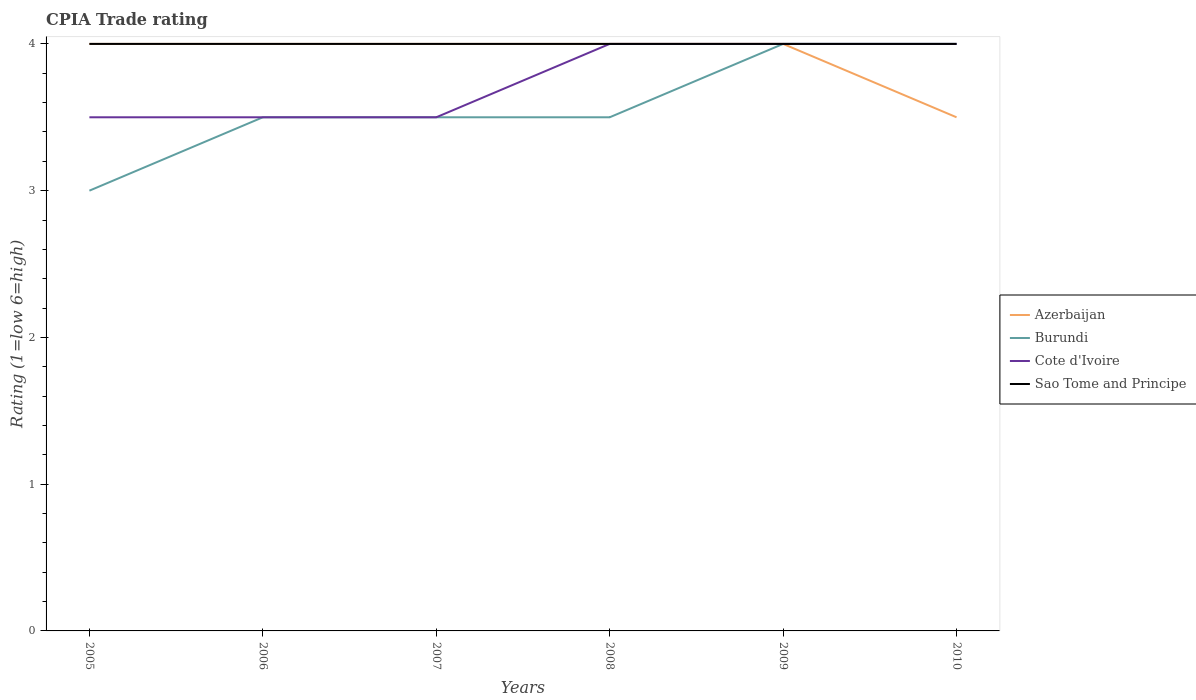In which year was the CPIA rating in Cote d'Ivoire maximum?
Provide a succinct answer. 2005. What is the total CPIA rating in Cote d'Ivoire in the graph?
Offer a very short reply. -0.5. What is the difference between the highest and the second highest CPIA rating in Sao Tome and Principe?
Keep it short and to the point. 0. What is the difference between the highest and the lowest CPIA rating in Azerbaijan?
Your response must be concise. 5. Is the CPIA rating in Cote d'Ivoire strictly greater than the CPIA rating in Azerbaijan over the years?
Ensure brevity in your answer.  No. How many lines are there?
Your answer should be very brief. 4. How many years are there in the graph?
Offer a very short reply. 6. Does the graph contain grids?
Provide a short and direct response. No. What is the title of the graph?
Your answer should be very brief. CPIA Trade rating. Does "Albania" appear as one of the legend labels in the graph?
Offer a terse response. No. What is the Rating (1=low 6=high) in Azerbaijan in 2005?
Keep it short and to the point. 4. What is the Rating (1=low 6=high) in Burundi in 2005?
Your answer should be very brief. 3. What is the Rating (1=low 6=high) in Azerbaijan in 2006?
Offer a terse response. 4. What is the Rating (1=low 6=high) in Cote d'Ivoire in 2006?
Provide a succinct answer. 3.5. What is the Rating (1=low 6=high) in Azerbaijan in 2007?
Provide a succinct answer. 4. What is the Rating (1=low 6=high) in Burundi in 2007?
Offer a very short reply. 3.5. What is the Rating (1=low 6=high) in Cote d'Ivoire in 2007?
Offer a terse response. 3.5. What is the Rating (1=low 6=high) of Azerbaijan in 2008?
Your answer should be very brief. 4. What is the Rating (1=low 6=high) of Burundi in 2008?
Provide a short and direct response. 3.5. What is the Rating (1=low 6=high) of Cote d'Ivoire in 2008?
Provide a short and direct response. 4. What is the Rating (1=low 6=high) in Azerbaijan in 2009?
Provide a succinct answer. 4. What is the Rating (1=low 6=high) in Burundi in 2009?
Ensure brevity in your answer.  4. What is the Rating (1=low 6=high) of Azerbaijan in 2010?
Your answer should be compact. 3.5. What is the Rating (1=low 6=high) in Sao Tome and Principe in 2010?
Provide a succinct answer. 4. Across all years, what is the maximum Rating (1=low 6=high) in Azerbaijan?
Offer a very short reply. 4. Across all years, what is the maximum Rating (1=low 6=high) in Burundi?
Your answer should be compact. 4. Across all years, what is the maximum Rating (1=low 6=high) of Sao Tome and Principe?
Provide a succinct answer. 4. Across all years, what is the minimum Rating (1=low 6=high) in Azerbaijan?
Provide a succinct answer. 3.5. Across all years, what is the minimum Rating (1=low 6=high) in Burundi?
Your answer should be very brief. 3. Across all years, what is the minimum Rating (1=low 6=high) of Sao Tome and Principe?
Your response must be concise. 4. What is the total Rating (1=low 6=high) of Azerbaijan in the graph?
Your answer should be very brief. 23.5. What is the total Rating (1=low 6=high) of Burundi in the graph?
Your answer should be compact. 21.5. What is the total Rating (1=low 6=high) of Cote d'Ivoire in the graph?
Offer a terse response. 22.5. What is the total Rating (1=low 6=high) of Sao Tome and Principe in the graph?
Provide a succinct answer. 24. What is the difference between the Rating (1=low 6=high) in Azerbaijan in 2005 and that in 2006?
Make the answer very short. 0. What is the difference between the Rating (1=low 6=high) in Cote d'Ivoire in 2005 and that in 2006?
Give a very brief answer. 0. What is the difference between the Rating (1=low 6=high) of Azerbaijan in 2005 and that in 2007?
Your answer should be very brief. 0. What is the difference between the Rating (1=low 6=high) in Cote d'Ivoire in 2005 and that in 2008?
Provide a succinct answer. -0.5. What is the difference between the Rating (1=low 6=high) of Azerbaijan in 2005 and that in 2009?
Ensure brevity in your answer.  0. What is the difference between the Rating (1=low 6=high) in Cote d'Ivoire in 2005 and that in 2009?
Your response must be concise. -0.5. What is the difference between the Rating (1=low 6=high) of Sao Tome and Principe in 2005 and that in 2009?
Offer a terse response. 0. What is the difference between the Rating (1=low 6=high) in Azerbaijan in 2005 and that in 2010?
Ensure brevity in your answer.  0.5. What is the difference between the Rating (1=low 6=high) in Sao Tome and Principe in 2006 and that in 2007?
Make the answer very short. 0. What is the difference between the Rating (1=low 6=high) in Azerbaijan in 2006 and that in 2008?
Provide a succinct answer. 0. What is the difference between the Rating (1=low 6=high) in Sao Tome and Principe in 2006 and that in 2008?
Provide a short and direct response. 0. What is the difference between the Rating (1=low 6=high) of Sao Tome and Principe in 2006 and that in 2009?
Your answer should be compact. 0. What is the difference between the Rating (1=low 6=high) of Burundi in 2006 and that in 2010?
Provide a short and direct response. -0.5. What is the difference between the Rating (1=low 6=high) of Azerbaijan in 2007 and that in 2008?
Give a very brief answer. 0. What is the difference between the Rating (1=low 6=high) of Burundi in 2007 and that in 2008?
Give a very brief answer. 0. What is the difference between the Rating (1=low 6=high) of Azerbaijan in 2007 and that in 2009?
Make the answer very short. 0. What is the difference between the Rating (1=low 6=high) of Burundi in 2007 and that in 2009?
Provide a succinct answer. -0.5. What is the difference between the Rating (1=low 6=high) in Cote d'Ivoire in 2007 and that in 2009?
Provide a succinct answer. -0.5. What is the difference between the Rating (1=low 6=high) in Sao Tome and Principe in 2007 and that in 2009?
Your answer should be compact. 0. What is the difference between the Rating (1=low 6=high) in Azerbaijan in 2007 and that in 2010?
Provide a succinct answer. 0.5. What is the difference between the Rating (1=low 6=high) in Sao Tome and Principe in 2007 and that in 2010?
Provide a succinct answer. 0. What is the difference between the Rating (1=low 6=high) of Azerbaijan in 2008 and that in 2009?
Your answer should be compact. 0. What is the difference between the Rating (1=low 6=high) of Cote d'Ivoire in 2008 and that in 2009?
Give a very brief answer. 0. What is the difference between the Rating (1=low 6=high) of Cote d'Ivoire in 2008 and that in 2010?
Offer a terse response. 0. What is the difference between the Rating (1=low 6=high) of Sao Tome and Principe in 2008 and that in 2010?
Your response must be concise. 0. What is the difference between the Rating (1=low 6=high) of Cote d'Ivoire in 2009 and that in 2010?
Provide a short and direct response. 0. What is the difference between the Rating (1=low 6=high) in Sao Tome and Principe in 2009 and that in 2010?
Your response must be concise. 0. What is the difference between the Rating (1=low 6=high) of Burundi in 2005 and the Rating (1=low 6=high) of Sao Tome and Principe in 2006?
Ensure brevity in your answer.  -1. What is the difference between the Rating (1=low 6=high) of Azerbaijan in 2005 and the Rating (1=low 6=high) of Sao Tome and Principe in 2007?
Provide a short and direct response. 0. What is the difference between the Rating (1=low 6=high) in Burundi in 2005 and the Rating (1=low 6=high) in Cote d'Ivoire in 2007?
Your answer should be very brief. -0.5. What is the difference between the Rating (1=low 6=high) of Cote d'Ivoire in 2005 and the Rating (1=low 6=high) of Sao Tome and Principe in 2007?
Your answer should be compact. -0.5. What is the difference between the Rating (1=low 6=high) in Burundi in 2005 and the Rating (1=low 6=high) in Cote d'Ivoire in 2008?
Offer a terse response. -1. What is the difference between the Rating (1=low 6=high) in Burundi in 2005 and the Rating (1=low 6=high) in Sao Tome and Principe in 2008?
Your answer should be compact. -1. What is the difference between the Rating (1=low 6=high) of Azerbaijan in 2005 and the Rating (1=low 6=high) of Burundi in 2009?
Provide a succinct answer. 0. What is the difference between the Rating (1=low 6=high) in Azerbaijan in 2005 and the Rating (1=low 6=high) in Sao Tome and Principe in 2009?
Provide a succinct answer. 0. What is the difference between the Rating (1=low 6=high) in Burundi in 2005 and the Rating (1=low 6=high) in Sao Tome and Principe in 2009?
Your response must be concise. -1. What is the difference between the Rating (1=low 6=high) of Azerbaijan in 2005 and the Rating (1=low 6=high) of Cote d'Ivoire in 2010?
Your answer should be compact. 0. What is the difference between the Rating (1=low 6=high) in Burundi in 2005 and the Rating (1=low 6=high) in Cote d'Ivoire in 2010?
Offer a very short reply. -1. What is the difference between the Rating (1=low 6=high) in Cote d'Ivoire in 2005 and the Rating (1=low 6=high) in Sao Tome and Principe in 2010?
Your answer should be compact. -0.5. What is the difference between the Rating (1=low 6=high) of Azerbaijan in 2006 and the Rating (1=low 6=high) of Cote d'Ivoire in 2007?
Make the answer very short. 0.5. What is the difference between the Rating (1=low 6=high) in Azerbaijan in 2006 and the Rating (1=low 6=high) in Sao Tome and Principe in 2007?
Your answer should be compact. 0. What is the difference between the Rating (1=low 6=high) in Burundi in 2006 and the Rating (1=low 6=high) in Cote d'Ivoire in 2007?
Provide a succinct answer. 0. What is the difference between the Rating (1=low 6=high) of Burundi in 2006 and the Rating (1=low 6=high) of Sao Tome and Principe in 2007?
Offer a terse response. -0.5. What is the difference between the Rating (1=low 6=high) of Cote d'Ivoire in 2006 and the Rating (1=low 6=high) of Sao Tome and Principe in 2007?
Keep it short and to the point. -0.5. What is the difference between the Rating (1=low 6=high) of Azerbaijan in 2006 and the Rating (1=low 6=high) of Burundi in 2008?
Offer a very short reply. 0.5. What is the difference between the Rating (1=low 6=high) in Azerbaijan in 2006 and the Rating (1=low 6=high) in Sao Tome and Principe in 2008?
Offer a terse response. 0. What is the difference between the Rating (1=low 6=high) in Burundi in 2006 and the Rating (1=low 6=high) in Sao Tome and Principe in 2008?
Your response must be concise. -0.5. What is the difference between the Rating (1=low 6=high) of Azerbaijan in 2006 and the Rating (1=low 6=high) of Burundi in 2009?
Offer a very short reply. 0. What is the difference between the Rating (1=low 6=high) in Burundi in 2006 and the Rating (1=low 6=high) in Cote d'Ivoire in 2009?
Provide a succinct answer. -0.5. What is the difference between the Rating (1=low 6=high) in Azerbaijan in 2006 and the Rating (1=low 6=high) in Cote d'Ivoire in 2010?
Offer a terse response. 0. What is the difference between the Rating (1=low 6=high) of Azerbaijan in 2006 and the Rating (1=low 6=high) of Sao Tome and Principe in 2010?
Your answer should be very brief. 0. What is the difference between the Rating (1=low 6=high) in Cote d'Ivoire in 2006 and the Rating (1=low 6=high) in Sao Tome and Principe in 2010?
Offer a very short reply. -0.5. What is the difference between the Rating (1=low 6=high) in Azerbaijan in 2007 and the Rating (1=low 6=high) in Sao Tome and Principe in 2008?
Your response must be concise. 0. What is the difference between the Rating (1=low 6=high) in Burundi in 2007 and the Rating (1=low 6=high) in Cote d'Ivoire in 2008?
Your answer should be very brief. -0.5. What is the difference between the Rating (1=low 6=high) of Azerbaijan in 2007 and the Rating (1=low 6=high) of Burundi in 2009?
Offer a terse response. 0. What is the difference between the Rating (1=low 6=high) in Azerbaijan in 2007 and the Rating (1=low 6=high) in Sao Tome and Principe in 2009?
Your response must be concise. 0. What is the difference between the Rating (1=low 6=high) of Burundi in 2007 and the Rating (1=low 6=high) of Cote d'Ivoire in 2009?
Provide a succinct answer. -0.5. What is the difference between the Rating (1=low 6=high) in Burundi in 2007 and the Rating (1=low 6=high) in Sao Tome and Principe in 2009?
Your answer should be very brief. -0.5. What is the difference between the Rating (1=low 6=high) of Cote d'Ivoire in 2007 and the Rating (1=low 6=high) of Sao Tome and Principe in 2009?
Provide a short and direct response. -0.5. What is the difference between the Rating (1=low 6=high) in Azerbaijan in 2007 and the Rating (1=low 6=high) in Burundi in 2010?
Keep it short and to the point. 0. What is the difference between the Rating (1=low 6=high) in Azerbaijan in 2007 and the Rating (1=low 6=high) in Cote d'Ivoire in 2010?
Ensure brevity in your answer.  0. What is the difference between the Rating (1=low 6=high) of Cote d'Ivoire in 2007 and the Rating (1=low 6=high) of Sao Tome and Principe in 2010?
Your answer should be very brief. -0.5. What is the difference between the Rating (1=low 6=high) in Azerbaijan in 2008 and the Rating (1=low 6=high) in Cote d'Ivoire in 2009?
Provide a succinct answer. 0. What is the difference between the Rating (1=low 6=high) in Azerbaijan in 2008 and the Rating (1=low 6=high) in Sao Tome and Principe in 2009?
Provide a succinct answer. 0. What is the difference between the Rating (1=low 6=high) in Burundi in 2008 and the Rating (1=low 6=high) in Cote d'Ivoire in 2009?
Ensure brevity in your answer.  -0.5. What is the difference between the Rating (1=low 6=high) in Burundi in 2008 and the Rating (1=low 6=high) in Sao Tome and Principe in 2009?
Provide a succinct answer. -0.5. What is the difference between the Rating (1=low 6=high) in Azerbaijan in 2008 and the Rating (1=low 6=high) in Sao Tome and Principe in 2010?
Provide a short and direct response. 0. What is the difference between the Rating (1=low 6=high) in Burundi in 2008 and the Rating (1=low 6=high) in Sao Tome and Principe in 2010?
Your answer should be very brief. -0.5. What is the difference between the Rating (1=low 6=high) of Azerbaijan in 2009 and the Rating (1=low 6=high) of Burundi in 2010?
Provide a succinct answer. 0. What is the difference between the Rating (1=low 6=high) in Azerbaijan in 2009 and the Rating (1=low 6=high) in Cote d'Ivoire in 2010?
Provide a short and direct response. 0. What is the difference between the Rating (1=low 6=high) in Azerbaijan in 2009 and the Rating (1=low 6=high) in Sao Tome and Principe in 2010?
Keep it short and to the point. 0. What is the difference between the Rating (1=low 6=high) in Cote d'Ivoire in 2009 and the Rating (1=low 6=high) in Sao Tome and Principe in 2010?
Give a very brief answer. 0. What is the average Rating (1=low 6=high) in Azerbaijan per year?
Make the answer very short. 3.92. What is the average Rating (1=low 6=high) in Burundi per year?
Your response must be concise. 3.58. What is the average Rating (1=low 6=high) in Cote d'Ivoire per year?
Provide a succinct answer. 3.75. In the year 2005, what is the difference between the Rating (1=low 6=high) in Azerbaijan and Rating (1=low 6=high) in Cote d'Ivoire?
Provide a succinct answer. 0.5. In the year 2005, what is the difference between the Rating (1=low 6=high) of Azerbaijan and Rating (1=low 6=high) of Sao Tome and Principe?
Offer a very short reply. 0. In the year 2005, what is the difference between the Rating (1=low 6=high) in Burundi and Rating (1=low 6=high) in Cote d'Ivoire?
Give a very brief answer. -0.5. In the year 2006, what is the difference between the Rating (1=low 6=high) of Azerbaijan and Rating (1=low 6=high) of Sao Tome and Principe?
Offer a terse response. 0. In the year 2006, what is the difference between the Rating (1=low 6=high) in Burundi and Rating (1=low 6=high) in Sao Tome and Principe?
Provide a succinct answer. -0.5. In the year 2007, what is the difference between the Rating (1=low 6=high) in Azerbaijan and Rating (1=low 6=high) in Sao Tome and Principe?
Provide a short and direct response. 0. In the year 2007, what is the difference between the Rating (1=low 6=high) in Cote d'Ivoire and Rating (1=low 6=high) in Sao Tome and Principe?
Your answer should be compact. -0.5. In the year 2008, what is the difference between the Rating (1=low 6=high) of Azerbaijan and Rating (1=low 6=high) of Sao Tome and Principe?
Make the answer very short. 0. In the year 2008, what is the difference between the Rating (1=low 6=high) of Burundi and Rating (1=low 6=high) of Cote d'Ivoire?
Your answer should be very brief. -0.5. In the year 2008, what is the difference between the Rating (1=low 6=high) of Burundi and Rating (1=low 6=high) of Sao Tome and Principe?
Provide a succinct answer. -0.5. In the year 2008, what is the difference between the Rating (1=low 6=high) in Cote d'Ivoire and Rating (1=low 6=high) in Sao Tome and Principe?
Give a very brief answer. 0. In the year 2009, what is the difference between the Rating (1=low 6=high) of Burundi and Rating (1=low 6=high) of Cote d'Ivoire?
Your answer should be very brief. 0. In the year 2009, what is the difference between the Rating (1=low 6=high) of Cote d'Ivoire and Rating (1=low 6=high) of Sao Tome and Principe?
Provide a succinct answer. 0. In the year 2010, what is the difference between the Rating (1=low 6=high) of Azerbaijan and Rating (1=low 6=high) of Sao Tome and Principe?
Your response must be concise. -0.5. What is the ratio of the Rating (1=low 6=high) in Cote d'Ivoire in 2005 to that in 2006?
Your answer should be very brief. 1. What is the ratio of the Rating (1=low 6=high) of Azerbaijan in 2005 to that in 2007?
Ensure brevity in your answer.  1. What is the ratio of the Rating (1=low 6=high) in Sao Tome and Principe in 2005 to that in 2008?
Ensure brevity in your answer.  1. What is the ratio of the Rating (1=low 6=high) of Burundi in 2005 to that in 2009?
Offer a terse response. 0.75. What is the ratio of the Rating (1=low 6=high) of Sao Tome and Principe in 2005 to that in 2009?
Your answer should be compact. 1. What is the ratio of the Rating (1=low 6=high) in Azerbaijan in 2005 to that in 2010?
Provide a succinct answer. 1.14. What is the ratio of the Rating (1=low 6=high) in Burundi in 2005 to that in 2010?
Your answer should be very brief. 0.75. What is the ratio of the Rating (1=low 6=high) in Cote d'Ivoire in 2005 to that in 2010?
Provide a succinct answer. 0.88. What is the ratio of the Rating (1=low 6=high) in Burundi in 2006 to that in 2007?
Make the answer very short. 1. What is the ratio of the Rating (1=low 6=high) in Burundi in 2006 to that in 2008?
Give a very brief answer. 1. What is the ratio of the Rating (1=low 6=high) in Cote d'Ivoire in 2006 to that in 2008?
Keep it short and to the point. 0.88. What is the ratio of the Rating (1=low 6=high) of Sao Tome and Principe in 2006 to that in 2008?
Make the answer very short. 1. What is the ratio of the Rating (1=low 6=high) of Burundi in 2006 to that in 2009?
Provide a short and direct response. 0.88. What is the ratio of the Rating (1=low 6=high) in Cote d'Ivoire in 2006 to that in 2009?
Ensure brevity in your answer.  0.88. What is the ratio of the Rating (1=low 6=high) of Burundi in 2006 to that in 2010?
Keep it short and to the point. 0.88. What is the ratio of the Rating (1=low 6=high) in Cote d'Ivoire in 2006 to that in 2010?
Make the answer very short. 0.88. What is the ratio of the Rating (1=low 6=high) of Sao Tome and Principe in 2006 to that in 2010?
Offer a very short reply. 1. What is the ratio of the Rating (1=low 6=high) in Burundi in 2007 to that in 2008?
Your response must be concise. 1. What is the ratio of the Rating (1=low 6=high) of Sao Tome and Principe in 2007 to that in 2008?
Keep it short and to the point. 1. What is the ratio of the Rating (1=low 6=high) of Azerbaijan in 2007 to that in 2009?
Your answer should be very brief. 1. What is the ratio of the Rating (1=low 6=high) of Burundi in 2007 to that in 2009?
Provide a succinct answer. 0.88. What is the ratio of the Rating (1=low 6=high) in Cote d'Ivoire in 2007 to that in 2009?
Your answer should be very brief. 0.88. What is the ratio of the Rating (1=low 6=high) of Sao Tome and Principe in 2007 to that in 2009?
Your answer should be very brief. 1. What is the ratio of the Rating (1=low 6=high) of Azerbaijan in 2007 to that in 2010?
Ensure brevity in your answer.  1.14. What is the ratio of the Rating (1=low 6=high) in Sao Tome and Principe in 2007 to that in 2010?
Offer a terse response. 1. What is the ratio of the Rating (1=low 6=high) in Azerbaijan in 2008 to that in 2009?
Make the answer very short. 1. What is the ratio of the Rating (1=low 6=high) in Sao Tome and Principe in 2008 to that in 2009?
Make the answer very short. 1. What is the ratio of the Rating (1=low 6=high) of Cote d'Ivoire in 2008 to that in 2010?
Make the answer very short. 1. What is the ratio of the Rating (1=low 6=high) in Sao Tome and Principe in 2008 to that in 2010?
Provide a succinct answer. 1. What is the ratio of the Rating (1=low 6=high) in Azerbaijan in 2009 to that in 2010?
Provide a short and direct response. 1.14. What is the ratio of the Rating (1=low 6=high) of Burundi in 2009 to that in 2010?
Offer a terse response. 1. What is the ratio of the Rating (1=low 6=high) of Cote d'Ivoire in 2009 to that in 2010?
Make the answer very short. 1. What is the difference between the highest and the second highest Rating (1=low 6=high) in Azerbaijan?
Your answer should be very brief. 0. What is the difference between the highest and the lowest Rating (1=low 6=high) of Azerbaijan?
Offer a very short reply. 0.5. What is the difference between the highest and the lowest Rating (1=low 6=high) of Burundi?
Your answer should be very brief. 1. What is the difference between the highest and the lowest Rating (1=low 6=high) in Sao Tome and Principe?
Ensure brevity in your answer.  0. 